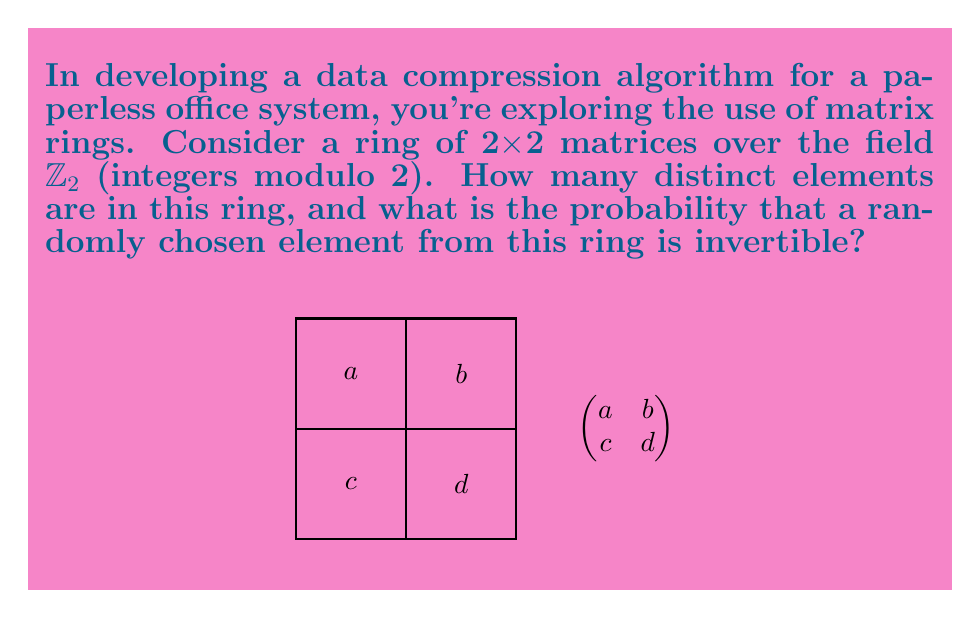What is the answer to this math problem? Let's approach this step-by-step:

1) First, we need to determine how many distinct elements are in the ring.
   - Each entry in the 2x2 matrix can be either 0 or 1 (since we're working in $\mathbb{Z}_2$).
   - There are 4 entries in a 2x2 matrix.
   - Therefore, the total number of distinct matrices is $2^4 = 16$.

2) Now, let's consider which of these matrices are invertible.
   - A matrix is invertible if and only if its determinant is non-zero.
   - For a 2x2 matrix $\begin{pmatrix} a & b \\ c & d \end{pmatrix}$, the determinant is $ad - bc$.
   - In $\mathbb{Z}_2$, this determinant will be 0 if $ad = bc$ (mod 2).

3) Let's count the invertible matrices:
   - The zero matrix $\begin{pmatrix} 0 & 0 \\ 0 & 0 \end{pmatrix}$ is not invertible.
   - Matrices of the form $\begin{pmatrix} 1 & 0 \\ 0 & 1 \end{pmatrix}$, $\begin{pmatrix} 0 & 1 \\ 1 & 0 \end{pmatrix}$, $\begin{pmatrix} 1 & 1 \\ 1 & 1 \end{pmatrix}$ are invertible.
   - Other invertible matrices: $\begin{pmatrix} 1 & 0 \\ 1 & 1 \end{pmatrix}$, $\begin{pmatrix} 1 & 1 \\ 0 & 1 \end{pmatrix}$, $\begin{pmatrix} 1 & 1 \\ 1 & 0 \end{pmatrix}$.
   - In total, there are 6 invertible matrices.

4) The probability of choosing an invertible matrix randomly:
   $P(\text{invertible}) = \frac{\text{number of invertible matrices}}{\text{total number of matrices}} = \frac{6}{16} = \frac{3}{8}$

This analysis can be useful in developing compression algorithms, as understanding the structure of the matrix ring can lead to more efficient encoding and decoding processes.
Answer: 16 elements; $\frac{3}{8}$ probability of being invertible 